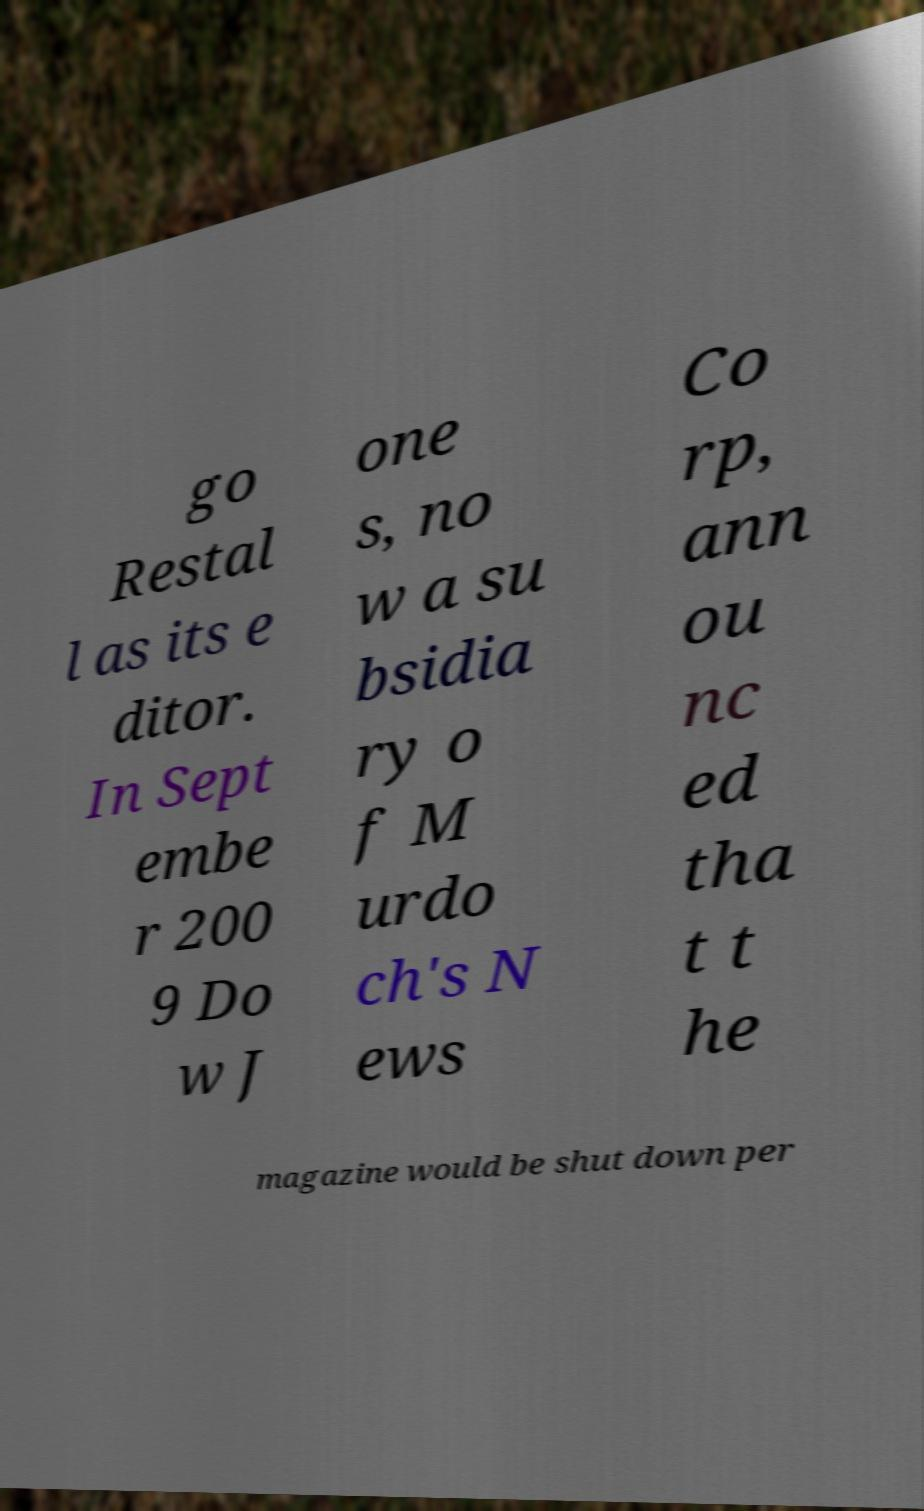What messages or text are displayed in this image? I need them in a readable, typed format. go Restal l as its e ditor. In Sept embe r 200 9 Do w J one s, no w a su bsidia ry o f M urdo ch's N ews Co rp, ann ou nc ed tha t t he magazine would be shut down per 